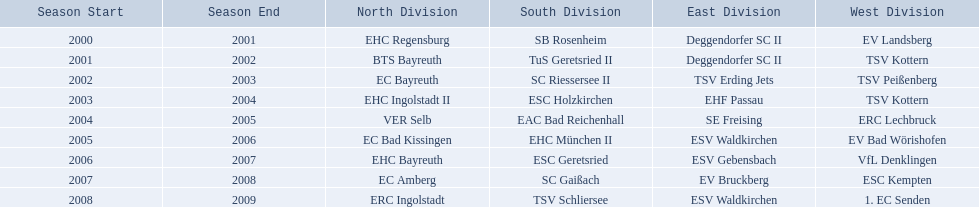Which teams played in the north? EHC Regensburg, BTS Bayreuth, EC Bayreuth, EHC Ingolstadt II, VER Selb, EC Bad Kissingen, EHC Bayreuth, EC Amberg, ERC Ingolstadt. Of these teams, which played during 2000-2001? EHC Regensburg. 